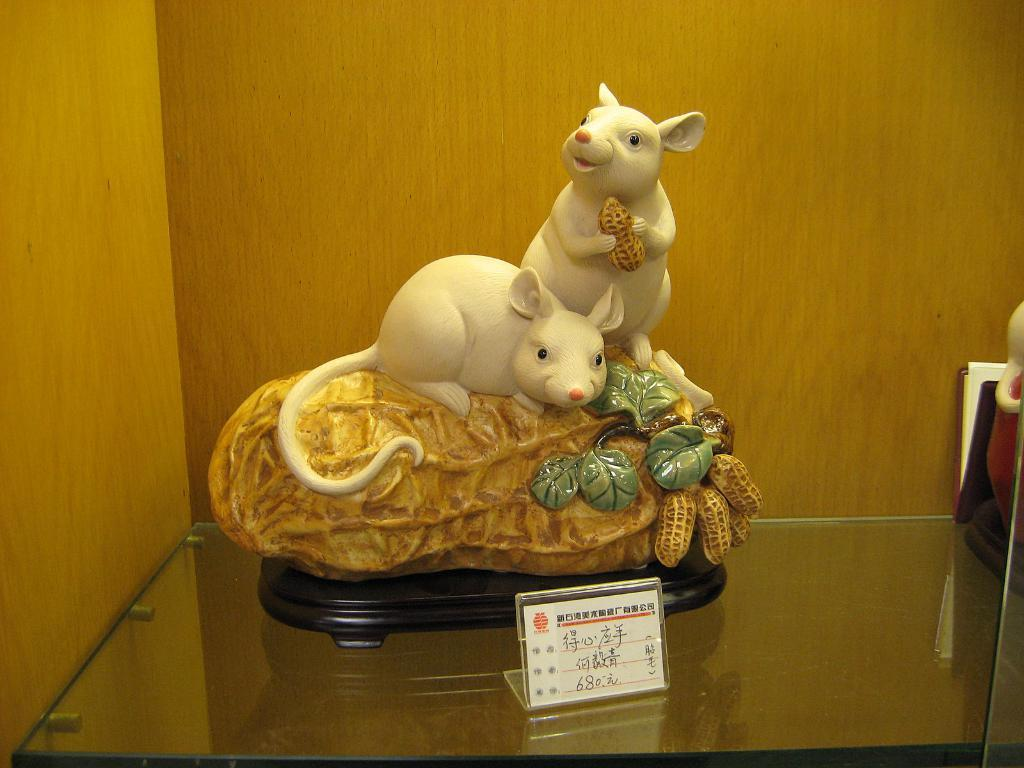What is the main subject in the image? There is a statue in the image. What else can be seen in the image besides the statue? There is a board and objects on a glass shelf visible in the image. What is the background of the image made of? The background of the image includes a wooden wall. What is the profit margin of the railway depicted in the image? There is no railway present in the image, so it is not possible to determine the profit margin. 